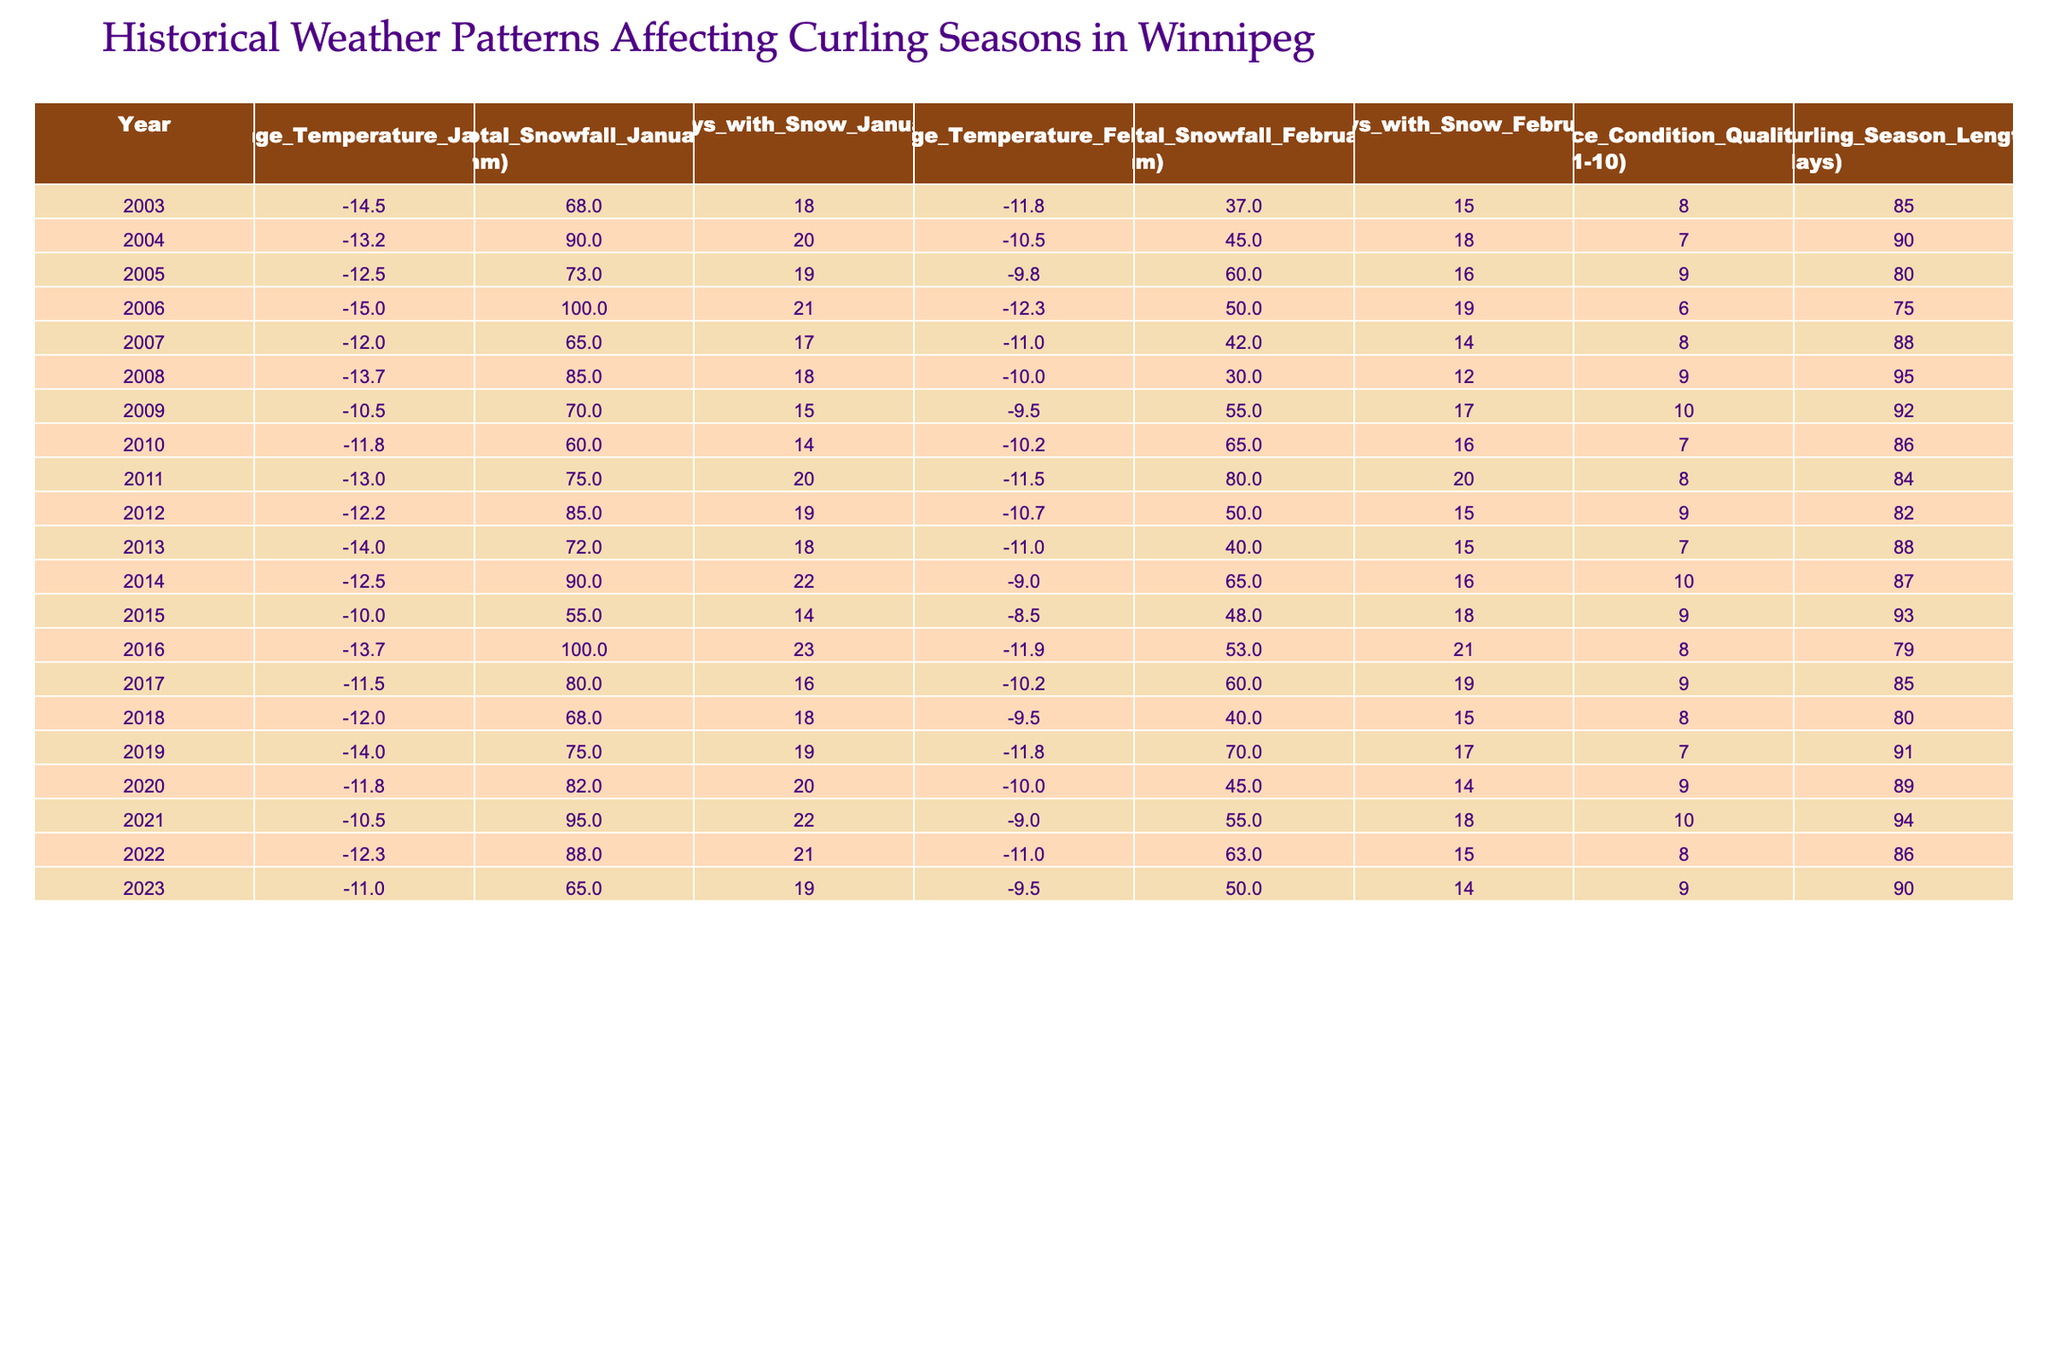What's the highest average temperature recorded in January during the last 20 years? From the table, I look for the 'Average_Temperature_January (°C)' column and find the maximum value, which is -10.0°C in 2015.
Answer: -10.0°C In which year did Winnipeg have the most snowfall in January? I check the 'Total_Snowfall_January (mm)' column to find the maximum snowfall amount, which is 100.0 mm in 2006.
Answer: 2006 What was the average curling season length over the last 20 years? To find the average, I sum up all the 'Curling_Season_Length (days)' values and divide by 20. The total is 1744 days, so the average is 1744/20 = 87.2 days.
Answer: 87.2 days Which year had the best ice condition quality and what was that rating? I look at the 'Ice_Condition_Quality (1-10)' column and find the maximum rating of 10 in 2009 and 2021.
Answer: 10 in 2009 and 2021 Was there an increase in snow days from January 2021 to January 2022? I compare the 'Days_with_Snow_January' for both years: 22 days in 2021 and 21 days in 2022, which shows a decrease.
Answer: No What years had a curling season length of 90 days or more? I look through the 'Curling_Season_Length (days)' column and identify the years 2004, 2008, 2009, 2015, and 2021, where the length was 90 days or more.
Answer: 2004, 2008, 2009, 2015, and 2021 What was the average snowfall for February across all 20 years? I sum the 'Total_Snowfall_February (mm)' for all years, which yields 1033.0 mm. Dividing by 20 gives an average of 51.65 mm.
Answer: 51.65 mm Which year had a higher total snowfall in February than January? I examine the total snowfall columns for each year: February had more than January in 2004, 2005, 2006, 2011, 2014, 2019, and 2021.
Answer: 2004, 2005, 2006, 2011, 2014, 2019, and 2021 How did ice condition quality correlate with curling season length in 2008? The ice condition quality was rated 9 in 2008, and the curling season length was 95 days. An exploratory look shows higher quality often corresponds with longer seasons.
Answer: 9 and 95 days correlate positively 